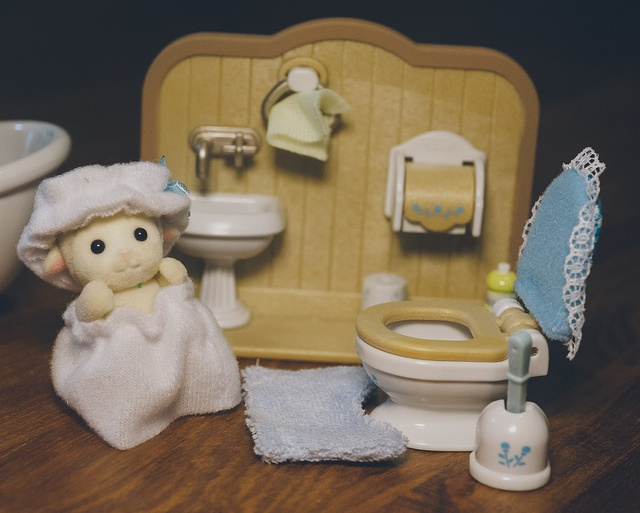Describe the objects in this image and their specific colors. I can see toilet in black, tan, darkgray, and gray tones, teddy bear in black and tan tones, sink in black, darkgray, and gray tones, and sink in black, darkgray, and gray tones in this image. 